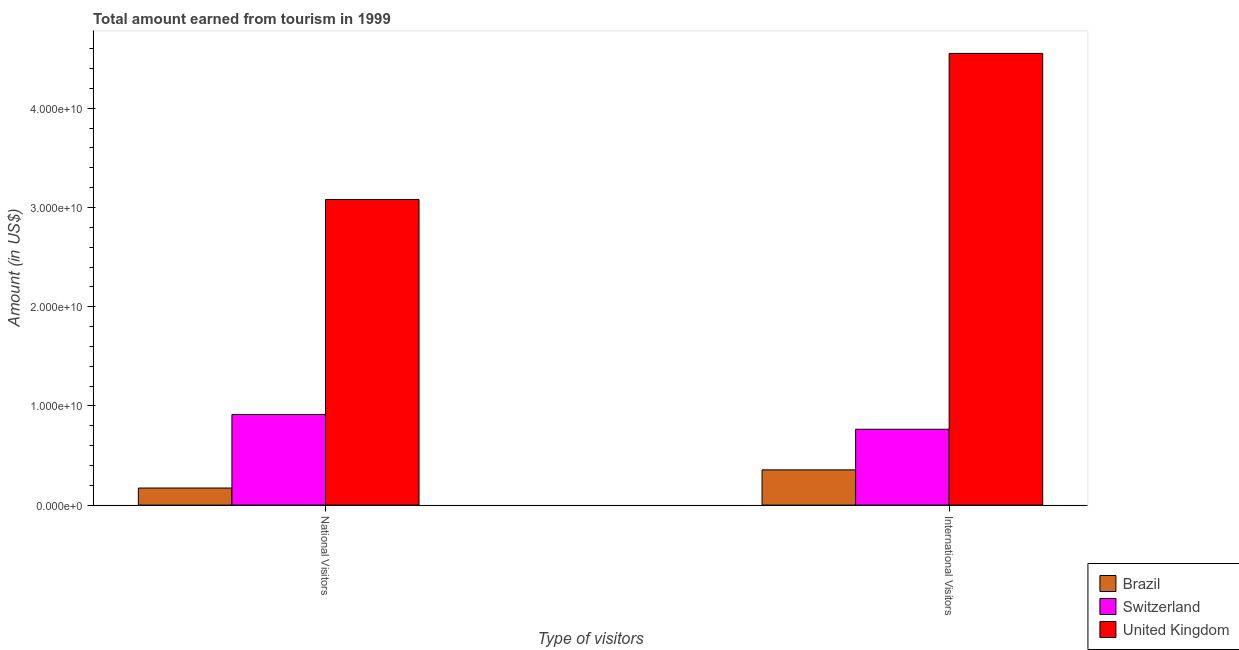How many groups of bars are there?
Make the answer very short. 2. Are the number of bars on each tick of the X-axis equal?
Make the answer very short. Yes. What is the label of the 2nd group of bars from the left?
Keep it short and to the point. International Visitors. What is the amount earned from international visitors in Switzerland?
Ensure brevity in your answer.  7.65e+09. Across all countries, what is the maximum amount earned from international visitors?
Ensure brevity in your answer.  4.55e+1. Across all countries, what is the minimum amount earned from international visitors?
Make the answer very short. 3.55e+09. In which country was the amount earned from international visitors maximum?
Offer a terse response. United Kingdom. In which country was the amount earned from international visitors minimum?
Your response must be concise. Brazil. What is the total amount earned from international visitors in the graph?
Ensure brevity in your answer.  5.67e+1. What is the difference between the amount earned from national visitors in Switzerland and that in Brazil?
Your answer should be compact. 7.42e+09. What is the difference between the amount earned from international visitors in United Kingdom and the amount earned from national visitors in Brazil?
Make the answer very short. 4.38e+1. What is the average amount earned from national visitors per country?
Make the answer very short. 1.39e+1. What is the difference between the amount earned from national visitors and amount earned from international visitors in United Kingdom?
Your answer should be very brief. -1.47e+1. What is the ratio of the amount earned from international visitors in Brazil to that in Switzerland?
Your answer should be compact. 0.46. Is the amount earned from national visitors in United Kingdom less than that in Brazil?
Offer a very short reply. No. In how many countries, is the amount earned from international visitors greater than the average amount earned from international visitors taken over all countries?
Give a very brief answer. 1. What does the 1st bar from the right in International Visitors represents?
Offer a very short reply. United Kingdom. Are all the bars in the graph horizontal?
Ensure brevity in your answer.  No. How many countries are there in the graph?
Keep it short and to the point. 3. What is the difference between two consecutive major ticks on the Y-axis?
Provide a short and direct response. 1.00e+1. Does the graph contain any zero values?
Provide a short and direct response. No. How many legend labels are there?
Provide a succinct answer. 3. How are the legend labels stacked?
Make the answer very short. Vertical. What is the title of the graph?
Make the answer very short. Total amount earned from tourism in 1999. Does "Yemen, Rep." appear as one of the legend labels in the graph?
Provide a succinct answer. No. What is the label or title of the X-axis?
Make the answer very short. Type of visitors. What is the label or title of the Y-axis?
Your response must be concise. Amount (in US$). What is the Amount (in US$) in Brazil in National Visitors?
Offer a terse response. 1.72e+09. What is the Amount (in US$) of Switzerland in National Visitors?
Your answer should be very brief. 9.14e+09. What is the Amount (in US$) of United Kingdom in National Visitors?
Give a very brief answer. 3.08e+1. What is the Amount (in US$) in Brazil in International Visitors?
Your response must be concise. 3.55e+09. What is the Amount (in US$) of Switzerland in International Visitors?
Provide a succinct answer. 7.65e+09. What is the Amount (in US$) in United Kingdom in International Visitors?
Your answer should be compact. 4.55e+1. Across all Type of visitors, what is the maximum Amount (in US$) in Brazil?
Offer a very short reply. 3.55e+09. Across all Type of visitors, what is the maximum Amount (in US$) in Switzerland?
Your answer should be compact. 9.14e+09. Across all Type of visitors, what is the maximum Amount (in US$) of United Kingdom?
Provide a succinct answer. 4.55e+1. Across all Type of visitors, what is the minimum Amount (in US$) in Brazil?
Your response must be concise. 1.72e+09. Across all Type of visitors, what is the minimum Amount (in US$) of Switzerland?
Keep it short and to the point. 7.65e+09. Across all Type of visitors, what is the minimum Amount (in US$) in United Kingdom?
Ensure brevity in your answer.  3.08e+1. What is the total Amount (in US$) in Brazil in the graph?
Provide a short and direct response. 5.27e+09. What is the total Amount (in US$) of Switzerland in the graph?
Provide a succinct answer. 1.68e+1. What is the total Amount (in US$) of United Kingdom in the graph?
Provide a succinct answer. 7.63e+1. What is the difference between the Amount (in US$) of Brazil in National Visitors and that in International Visitors?
Your answer should be compact. -1.83e+09. What is the difference between the Amount (in US$) of Switzerland in National Visitors and that in International Visitors?
Make the answer very short. 1.49e+09. What is the difference between the Amount (in US$) in United Kingdom in National Visitors and that in International Visitors?
Ensure brevity in your answer.  -1.47e+1. What is the difference between the Amount (in US$) of Brazil in National Visitors and the Amount (in US$) of Switzerland in International Visitors?
Your answer should be very brief. -5.93e+09. What is the difference between the Amount (in US$) in Brazil in National Visitors and the Amount (in US$) in United Kingdom in International Visitors?
Keep it short and to the point. -4.38e+1. What is the difference between the Amount (in US$) of Switzerland in National Visitors and the Amount (in US$) of United Kingdom in International Visitors?
Give a very brief answer. -3.64e+1. What is the average Amount (in US$) of Brazil per Type of visitors?
Provide a short and direct response. 2.63e+09. What is the average Amount (in US$) of Switzerland per Type of visitors?
Provide a succinct answer. 8.39e+09. What is the average Amount (in US$) of United Kingdom per Type of visitors?
Offer a terse response. 3.82e+1. What is the difference between the Amount (in US$) of Brazil and Amount (in US$) of Switzerland in National Visitors?
Keep it short and to the point. -7.42e+09. What is the difference between the Amount (in US$) of Brazil and Amount (in US$) of United Kingdom in National Visitors?
Provide a short and direct response. -2.91e+1. What is the difference between the Amount (in US$) of Switzerland and Amount (in US$) of United Kingdom in National Visitors?
Your response must be concise. -2.17e+1. What is the difference between the Amount (in US$) of Brazil and Amount (in US$) of Switzerland in International Visitors?
Your response must be concise. -4.10e+09. What is the difference between the Amount (in US$) of Brazil and Amount (in US$) of United Kingdom in International Visitors?
Provide a short and direct response. -4.20e+1. What is the difference between the Amount (in US$) in Switzerland and Amount (in US$) in United Kingdom in International Visitors?
Your answer should be compact. -3.79e+1. What is the ratio of the Amount (in US$) in Brazil in National Visitors to that in International Visitors?
Your response must be concise. 0.48. What is the ratio of the Amount (in US$) of Switzerland in National Visitors to that in International Visitors?
Keep it short and to the point. 1.19. What is the ratio of the Amount (in US$) of United Kingdom in National Visitors to that in International Visitors?
Offer a terse response. 0.68. What is the difference between the highest and the second highest Amount (in US$) in Brazil?
Ensure brevity in your answer.  1.83e+09. What is the difference between the highest and the second highest Amount (in US$) of Switzerland?
Keep it short and to the point. 1.49e+09. What is the difference between the highest and the second highest Amount (in US$) in United Kingdom?
Offer a very short reply. 1.47e+1. What is the difference between the highest and the lowest Amount (in US$) of Brazil?
Give a very brief answer. 1.83e+09. What is the difference between the highest and the lowest Amount (in US$) in Switzerland?
Provide a succinct answer. 1.49e+09. What is the difference between the highest and the lowest Amount (in US$) of United Kingdom?
Make the answer very short. 1.47e+1. 